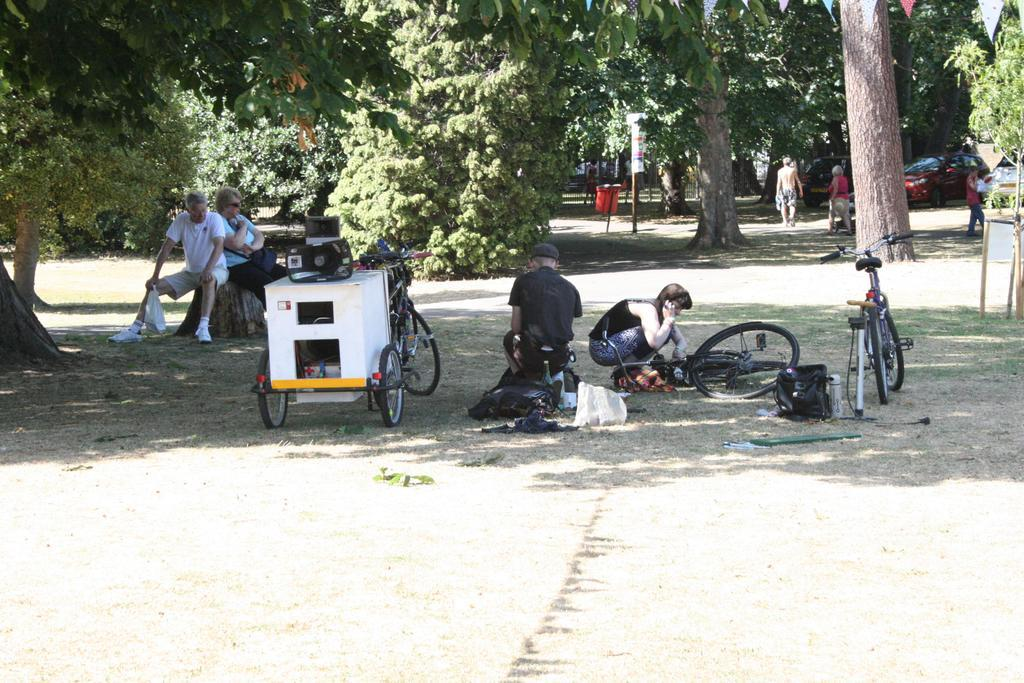What type of vehicles can be seen in the image? There are cars in the image. What objects are on the ground in the image? There are bicycles on the ground. What items are visible in the image that might be used for carrying belongings? There are bags and a cart in the image. What type of container is present in the image? There is a bottle in the image. What is used for amplifying sound in the image? There are loudspeakers in the image. How many people are present in the image? There are people in the image. What is used for disposing of waste in the image? There is a dustbin in the image. What type of objects are present in the image that do not fit into the other categories? There are other objects in the image. What can be seen in the background of the image? There are trees in the background of the image. What type of school can be seen in the image? There is no school present in the image. What type of office can be seen in the image? There is no office present in the image. 